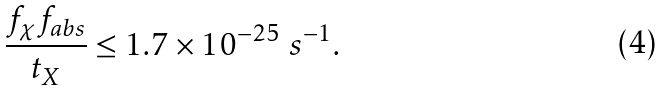Convert formula to latex. <formula><loc_0><loc_0><loc_500><loc_500>\frac { f _ { \chi } f _ { a b s } } { t _ { X } } \leq 1 . 7 \times 1 0 ^ { - 2 5 } \ s ^ { - 1 } .</formula> 